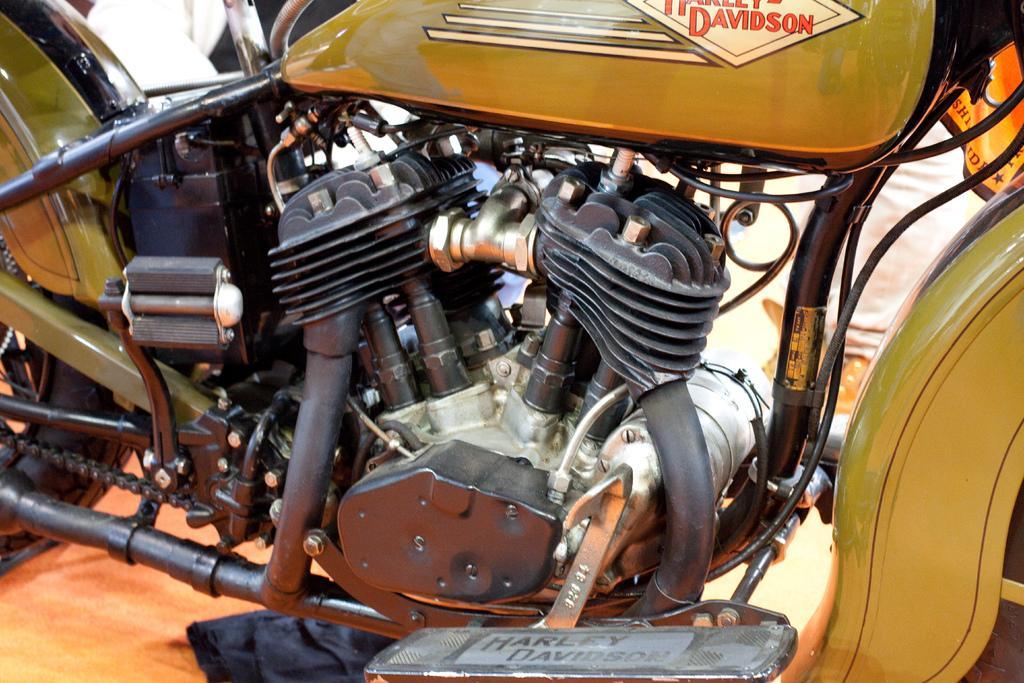How would you summarize this image in a sentence or two? In the picture we can see a engine of the motorcycle with pipes, wires, gear rod, chain, part of tire and a diesel tank and name on it as Harley Davidson. 